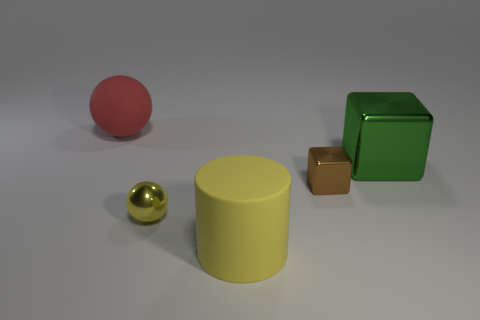Add 5 yellow metallic spheres. How many objects exist? 10 Subtract all cylinders. How many objects are left? 4 Subtract 0 cyan cylinders. How many objects are left? 5 Subtract all cyan balls. Subtract all yellow rubber cylinders. How many objects are left? 4 Add 2 small brown things. How many small brown things are left? 3 Add 2 green cubes. How many green cubes exist? 3 